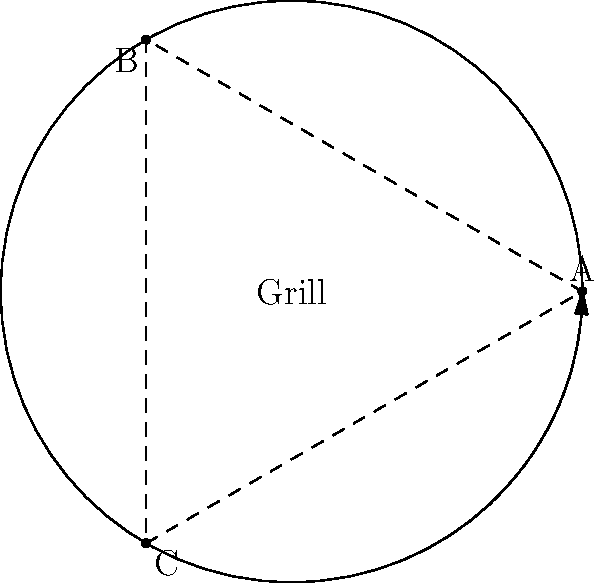A circular grill station with radius 2 meters is set up in the center of a backyard party. Three buffet tables (A, B, and C) are positioned around the grill at equal angular intervals. If a guest starts at table A and wants to visit all tables in a clockwise direction before returning to A, what is the total distance traveled in meters? Express your answer in terms of $\pi$. To solve this problem, we'll follow these steps:

1) First, we need to understand the layout:
   - The grill is at the center with a radius of 2 meters.
   - The tables are positioned at equal angular intervals, which means they form an equilateral triangle.
   - The angle between each table is $\frac{2\pi}{3}$ radians or 120°.

2) The path of the guest forms an equilateral triangle around the circle.

3) To find the length of this path, we need to calculate the arc length between each table:
   - Arc length formula: $s = r\theta$
   - Where $r = 2$ (radius) and $\theta = \frac{2\pi}{3}$ (angle in radians)
   - $s = 2 \cdot \frac{2\pi}{3} = \frac{4\pi}{3}$ meters

4) Since there are three equal arcs (A to B, B to C, and C back to A):
   - Total distance = $3 \cdot \frac{4\pi}{3} = 4\pi$ meters

Therefore, the total distance traveled is $4\pi$ meters.
Answer: $4\pi$ meters 